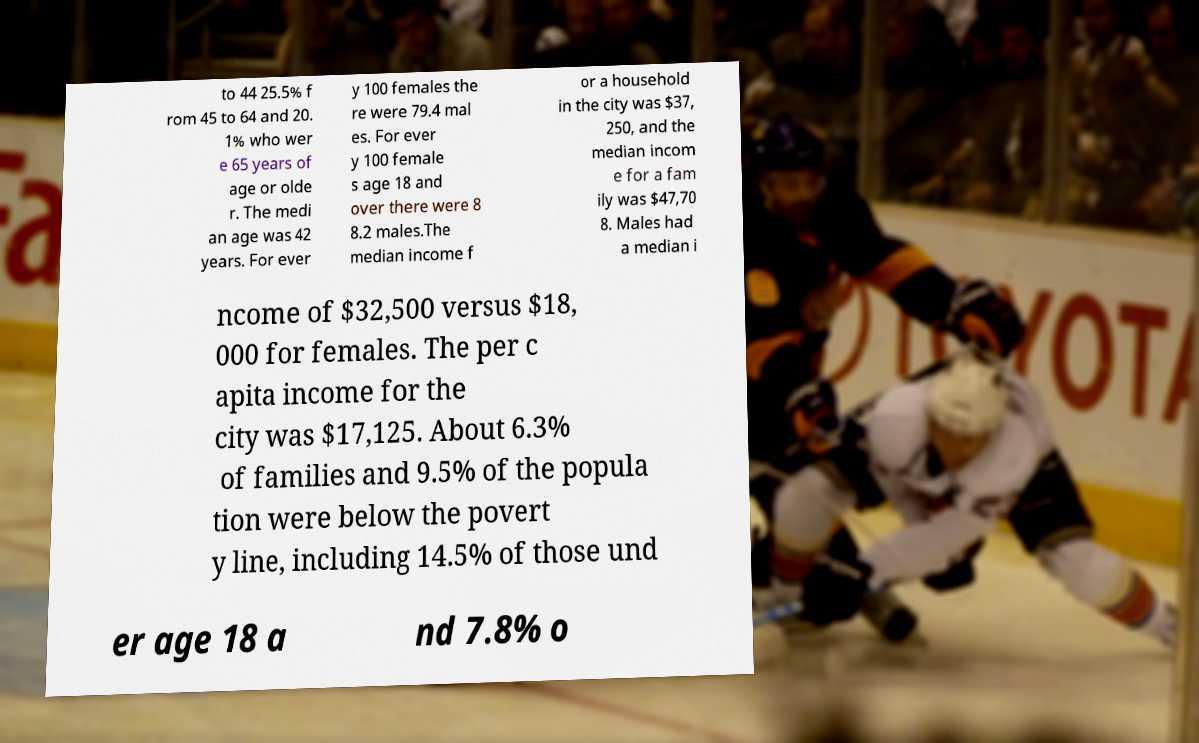For documentation purposes, I need the text within this image transcribed. Could you provide that? to 44 25.5% f rom 45 to 64 and 20. 1% who wer e 65 years of age or olde r. The medi an age was 42 years. For ever y 100 females the re were 79.4 mal es. For ever y 100 female s age 18 and over there were 8 8.2 males.The median income f or a household in the city was $37, 250, and the median incom e for a fam ily was $47,70 8. Males had a median i ncome of $32,500 versus $18, 000 for females. The per c apita income for the city was $17,125. About 6.3% of families and 9.5% of the popula tion were below the povert y line, including 14.5% of those und er age 18 a nd 7.8% o 